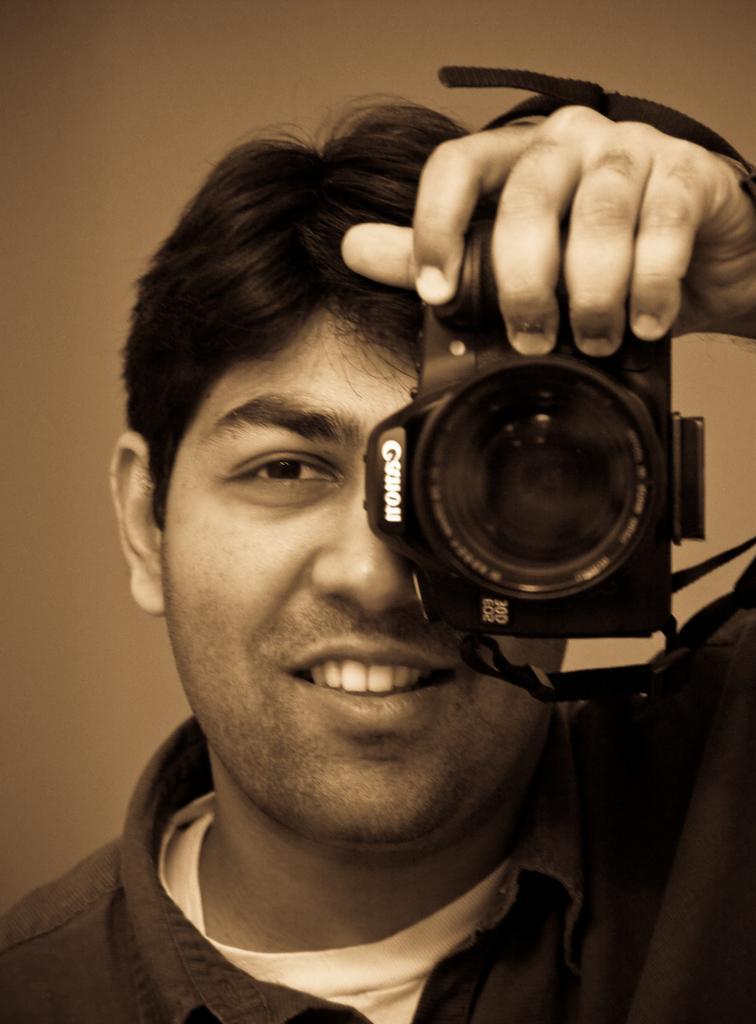Please provide a concise description of this image. I can see a man smiling and holding a camera in his hands. This camera is of canon company. 